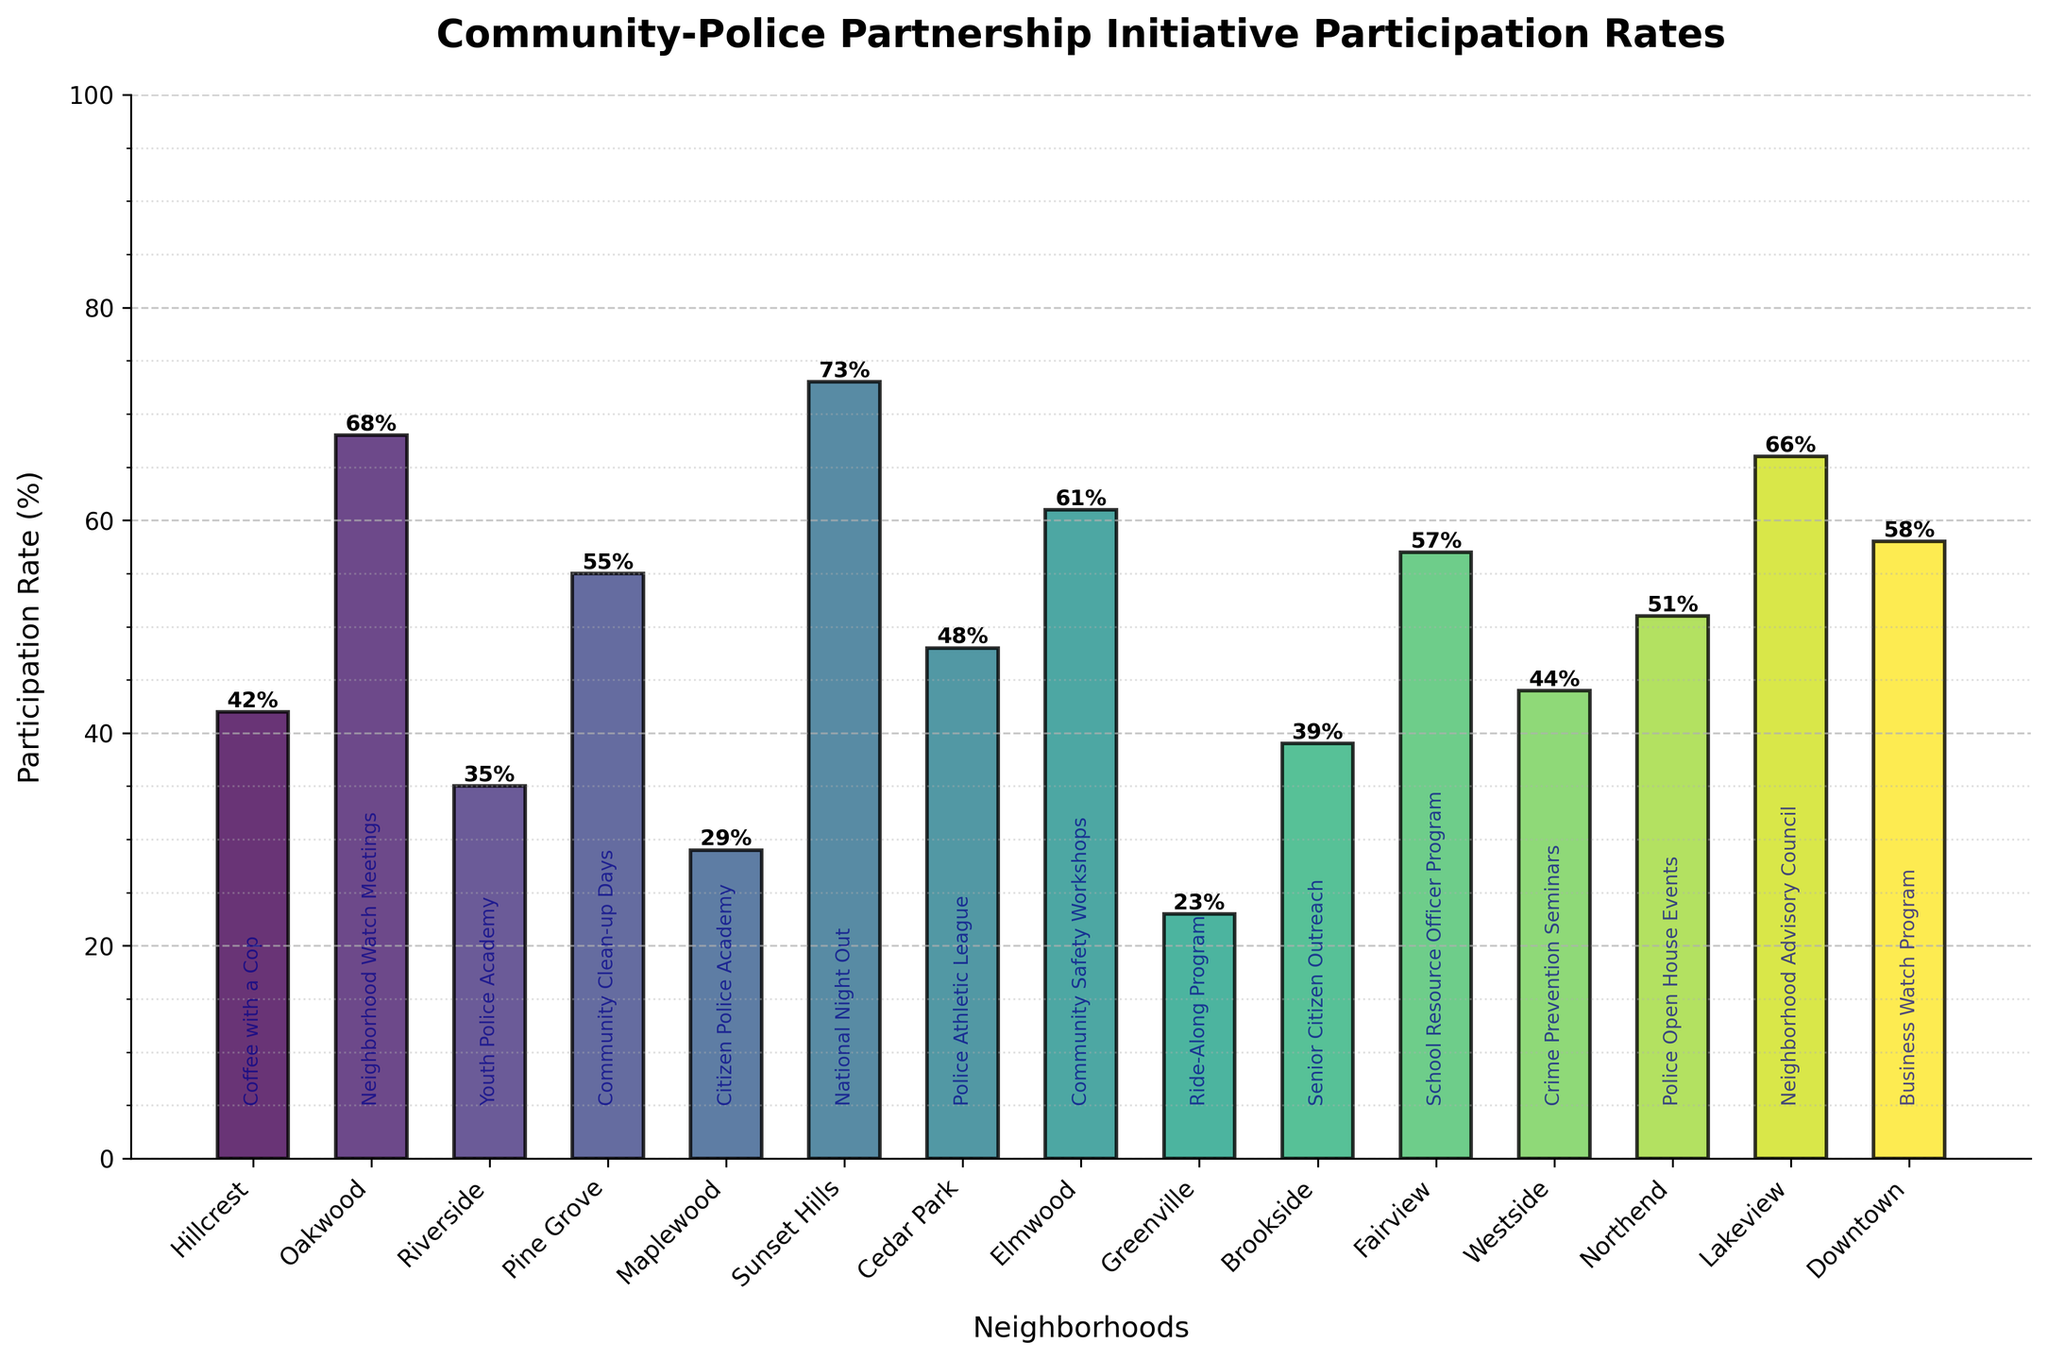Which neighborhood has the highest participation rate? By looking at the heights of the bars in the chart, the tallest bar corresponds to Sunset Hills.
Answer: Sunset Hills Which initiative in Greenville has the participation rate, and what is it? The chart shows labels at the top of each bar, and the bar for Greenville indicates the Ride-Along Program with a rate of 23%.
Answer: Ride-Along Program, 23% What is the difference in participation rates between Hillcrest and Oakwood? From the figure, Hillcrest has a participation rate of 42%, and Oakwood has a rate of 68%. The difference is 68 - 42.
Answer: 26% Which neighborhood has a participation rate just above the median participation rate of all neighborhoods? To find the answer, calculate the median of all participation rates, which is the middle value in a sorted list: [23, 29, 35, 39, 42, 44, 48, 51, 55, 57, 58, 61, 66, 68, 73]; the median is 51. The neighborhood with a participation rate just above 51 is Pine Grove.
Answer: Pine Grove How many neighborhoods have a participation rate greater than 50%? By scanning the chart, count the bars with heights above 50: Oakwood, Sunset Hills, Elmwood, Fairview, Lakeview, and Downtown. There are 6 bars above 50%.
Answer: 6 Which two neighborhoods have the most similar participation rates? By visually inspecting the chart, neighborhoods with the most similar heights of bars are Downtown (58%) and Fairview (57%), having only a 1% difference.
Answer: Downtown and Fairview What is the average participation rate for all neighborhoods? Sum all participation rates: 42 + 68 + 35 + 55 + 29 + 73 + 48 + 61 + 23 + 39 + 57 + 44 + 51 + 66 + 58 = 749. Divide by the number of neighborhoods, 15. 749/15 ≈ 49.93.
Answer: Approximately 49.93% Which initiative has the lowest participation rate and in which neighborhood? Scan the chart for the shortest bar, which corresponds to Greenville's Ride-Along Program at 23%.
Answer: Ride-Along Program, Greenville Compare the participation rates between 'Community Clean-up Days' in Pine Grove and 'National Night Out' in Sunset Hills. Which has a higher rate and by how much? Pine Grove has 55%, and Sunset Hills has 73%. The difference is 73 - 55.
Answer: Sunset Hills by 18% Which neighborhood with a "Police Open House Events" initiative and what is its participation rate? The annotation at the base of the bar shows Northend hosts "Police Open House Events" with a rate of 51%.
Answer: Northend, 51% 